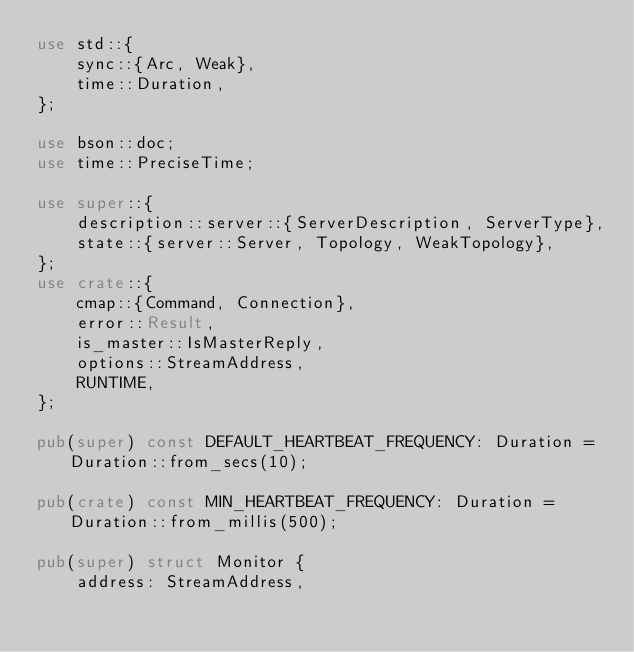Convert code to text. <code><loc_0><loc_0><loc_500><loc_500><_Rust_>use std::{
    sync::{Arc, Weak},
    time::Duration,
};

use bson::doc;
use time::PreciseTime;

use super::{
    description::server::{ServerDescription, ServerType},
    state::{server::Server, Topology, WeakTopology},
};
use crate::{
    cmap::{Command, Connection},
    error::Result,
    is_master::IsMasterReply,
    options::StreamAddress,
    RUNTIME,
};

pub(super) const DEFAULT_HEARTBEAT_FREQUENCY: Duration = Duration::from_secs(10);

pub(crate) const MIN_HEARTBEAT_FREQUENCY: Duration = Duration::from_millis(500);

pub(super) struct Monitor {
    address: StreamAddress,</code> 